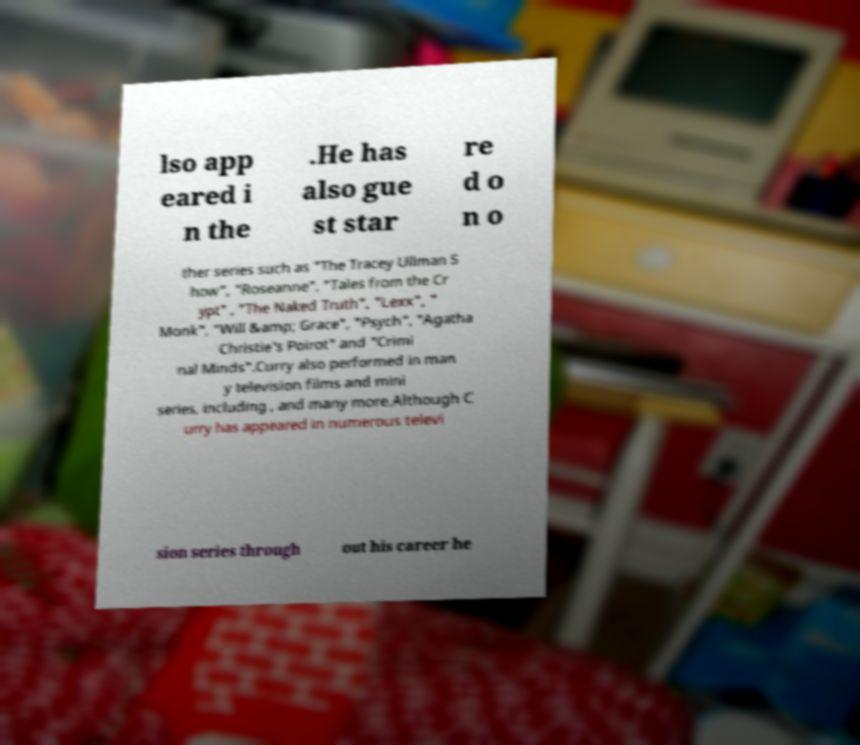Can you read and provide the text displayed in the image?This photo seems to have some interesting text. Can you extract and type it out for me? lso app eared i n the .He has also gue st star re d o n o ther series such as "The Tracey Ullman S how", "Roseanne", "Tales from the Cr ypt" , "The Naked Truth", "Lexx", " Monk", "Will &amp; Grace", "Psych", "Agatha Christie's Poirot" and "Crimi nal Minds".Curry also performed in man y television films and mini series, including , and many more.Although C urry has appeared in numerous televi sion series through out his career he 